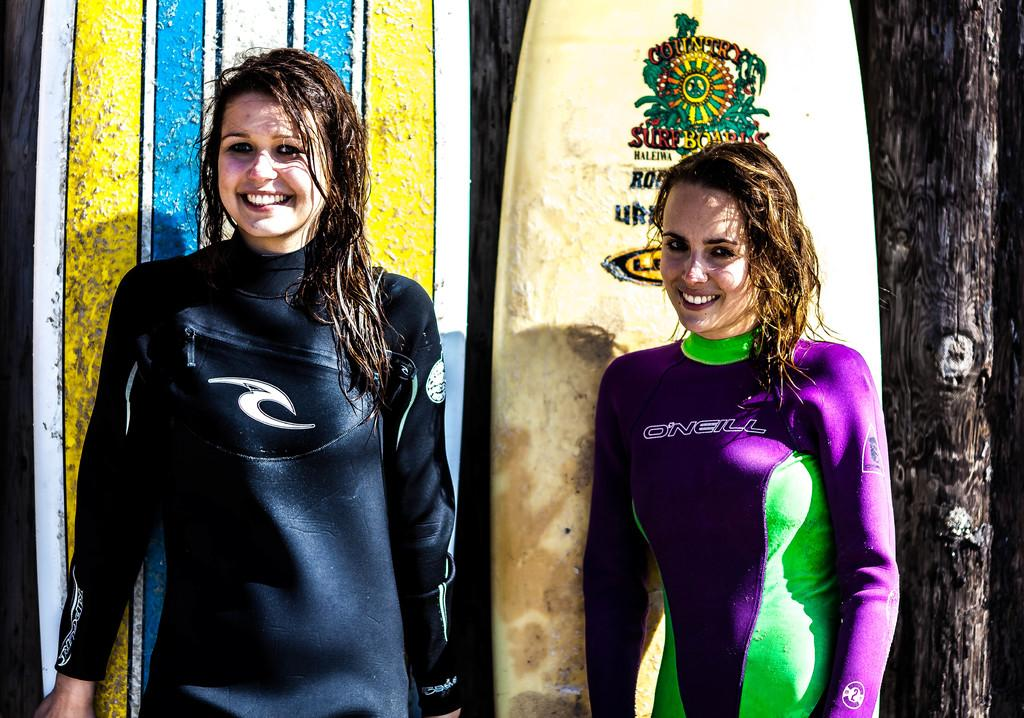How many people are in the image? There are two people in the image. What is the facial expression of the people? The people are smiling. What can be seen in the background behind the people? There are surfing boats behind the people. What type of vegetation is on the right side of the image? There is a tree on the right side of the image. Can you see any signs of destruction caused by a volcano in the image? There is no indication of a volcano or any destruction in the image. How many dimes are visible on the ground in the image? There are no dimes present in the image. 